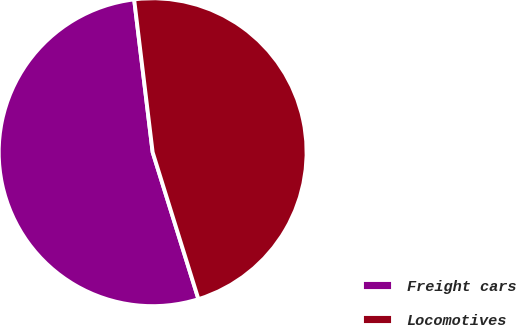Convert chart to OTSL. <chart><loc_0><loc_0><loc_500><loc_500><pie_chart><fcel>Freight cars<fcel>Locomotives<nl><fcel>52.89%<fcel>47.11%<nl></chart> 